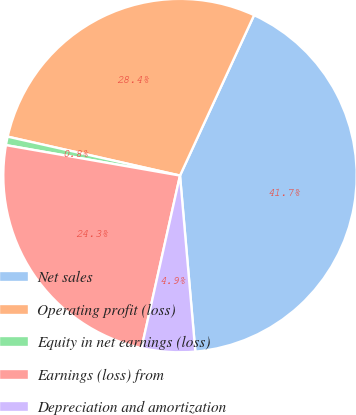<chart> <loc_0><loc_0><loc_500><loc_500><pie_chart><fcel>Net sales<fcel>Operating profit (loss)<fcel>Equity in net earnings (loss)<fcel>Earnings (loss) from<fcel>Depreciation and amortization<nl><fcel>41.73%<fcel>28.35%<fcel>0.78%<fcel>24.26%<fcel>4.88%<nl></chart> 